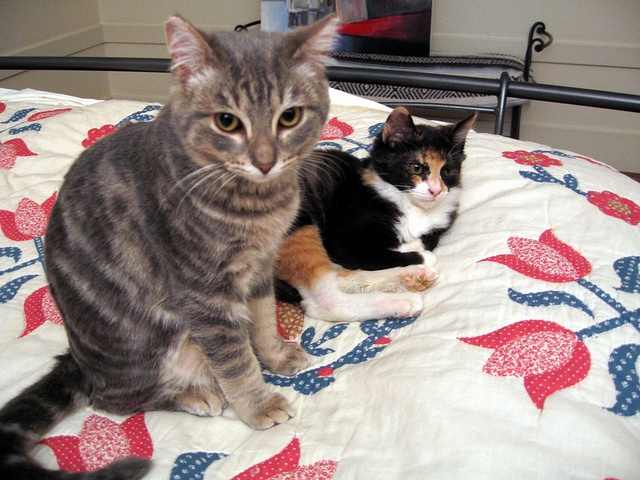Describe the objects in this image and their specific colors. I can see bed in gray, lightgray, salmon, and lightpink tones, cat in gray, black, and darkgray tones, and cat in gray, black, lightgray, and tan tones in this image. 